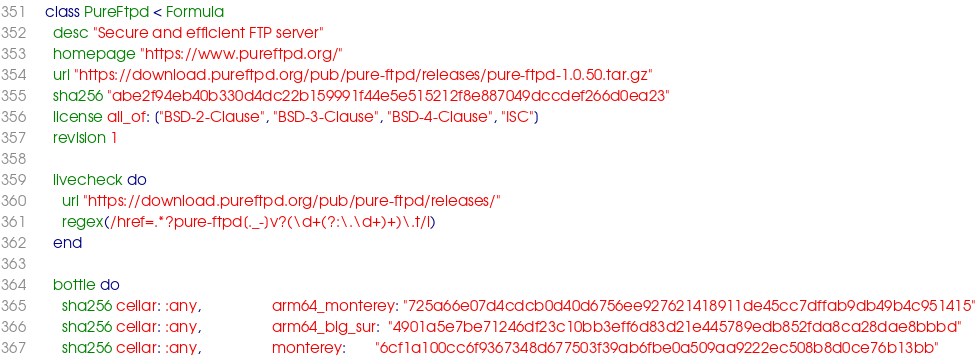<code> <loc_0><loc_0><loc_500><loc_500><_Ruby_>class PureFtpd < Formula
  desc "Secure and efficient FTP server"
  homepage "https://www.pureftpd.org/"
  url "https://download.pureftpd.org/pub/pure-ftpd/releases/pure-ftpd-1.0.50.tar.gz"
  sha256 "abe2f94eb40b330d4dc22b159991f44e5e515212f8e887049dccdef266d0ea23"
  license all_of: ["BSD-2-Clause", "BSD-3-Clause", "BSD-4-Clause", "ISC"]
  revision 1

  livecheck do
    url "https://download.pureftpd.org/pub/pure-ftpd/releases/"
    regex(/href=.*?pure-ftpd[._-]v?(\d+(?:\.\d+)+)\.t/i)
  end

  bottle do
    sha256 cellar: :any,                 arm64_monterey: "725a66e07d4cdcb0d40d6756ee927621418911de45cc7dffab9db49b4c951415"
    sha256 cellar: :any,                 arm64_big_sur:  "4901a5e7be71246df23c10bb3eff6d83d21e445789edb852fda8ca28dae8bbbd"
    sha256 cellar: :any,                 monterey:       "6cf1a100cc6f9367348d677503f39ab6fbe0a509aa9222ec508b8d0ce76b13bb"</code> 